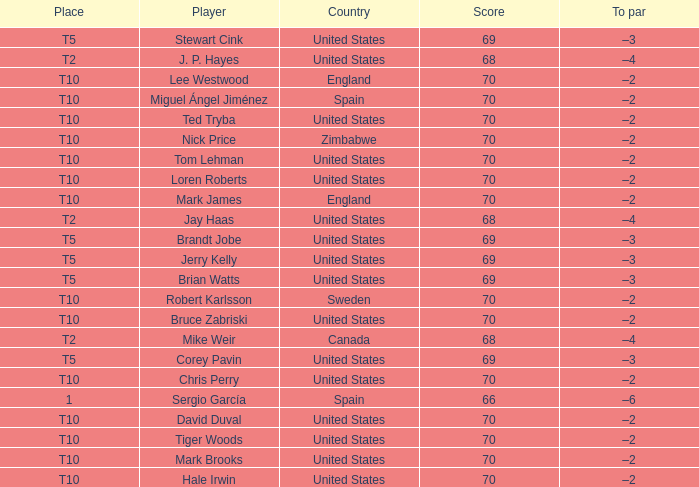What was the highest score of t5 place finisher brandt jobe? 69.0. 